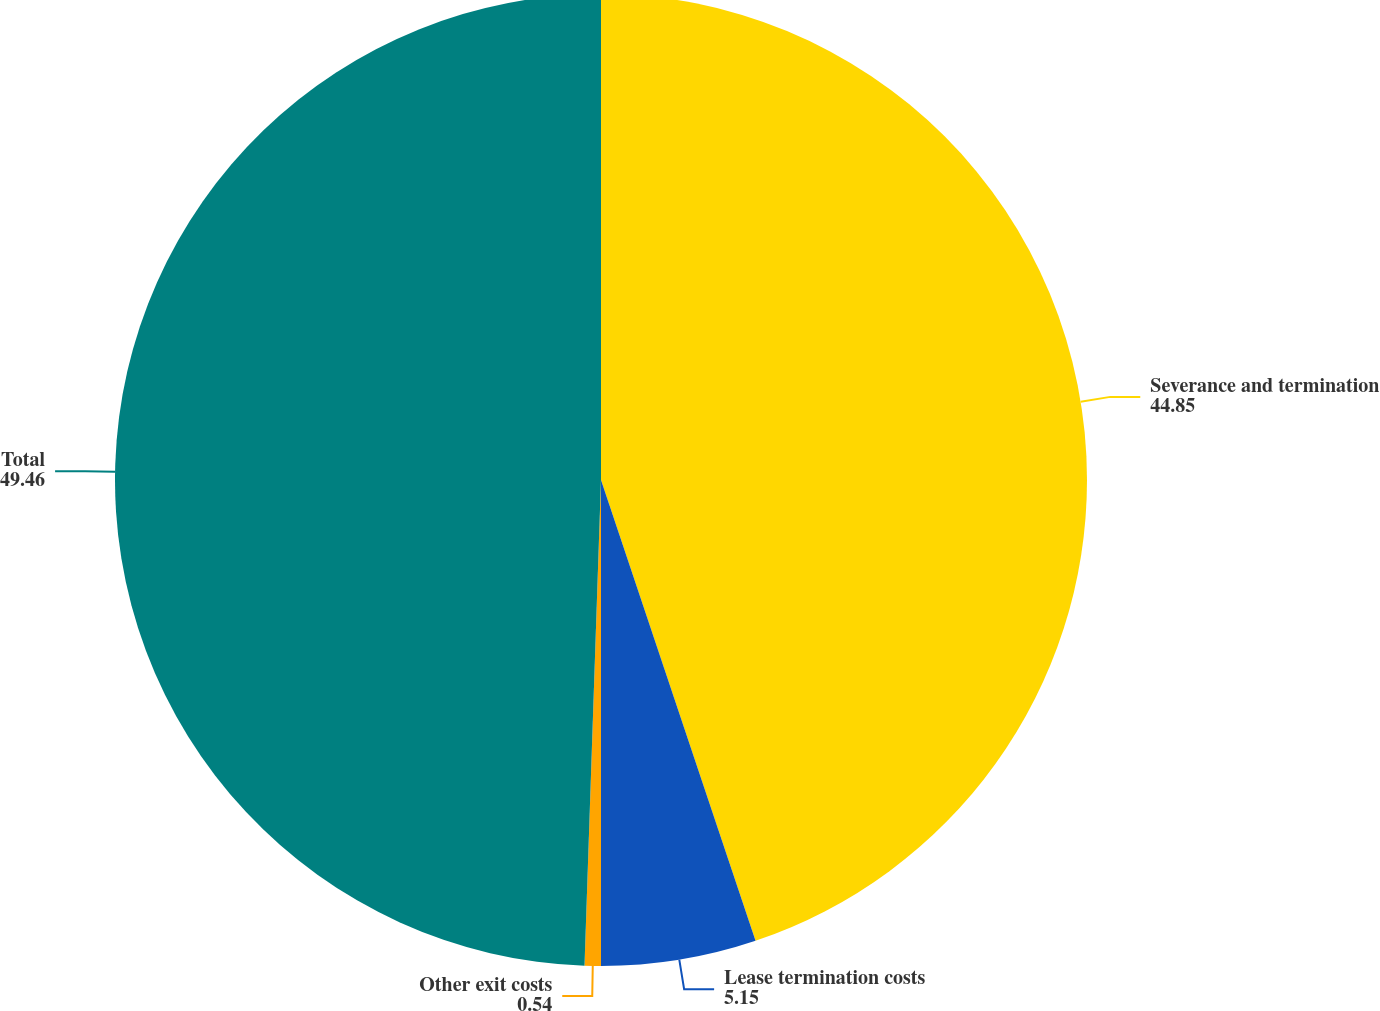Convert chart to OTSL. <chart><loc_0><loc_0><loc_500><loc_500><pie_chart><fcel>Severance and termination<fcel>Lease termination costs<fcel>Other exit costs<fcel>Total<nl><fcel>44.85%<fcel>5.15%<fcel>0.54%<fcel>49.46%<nl></chart> 